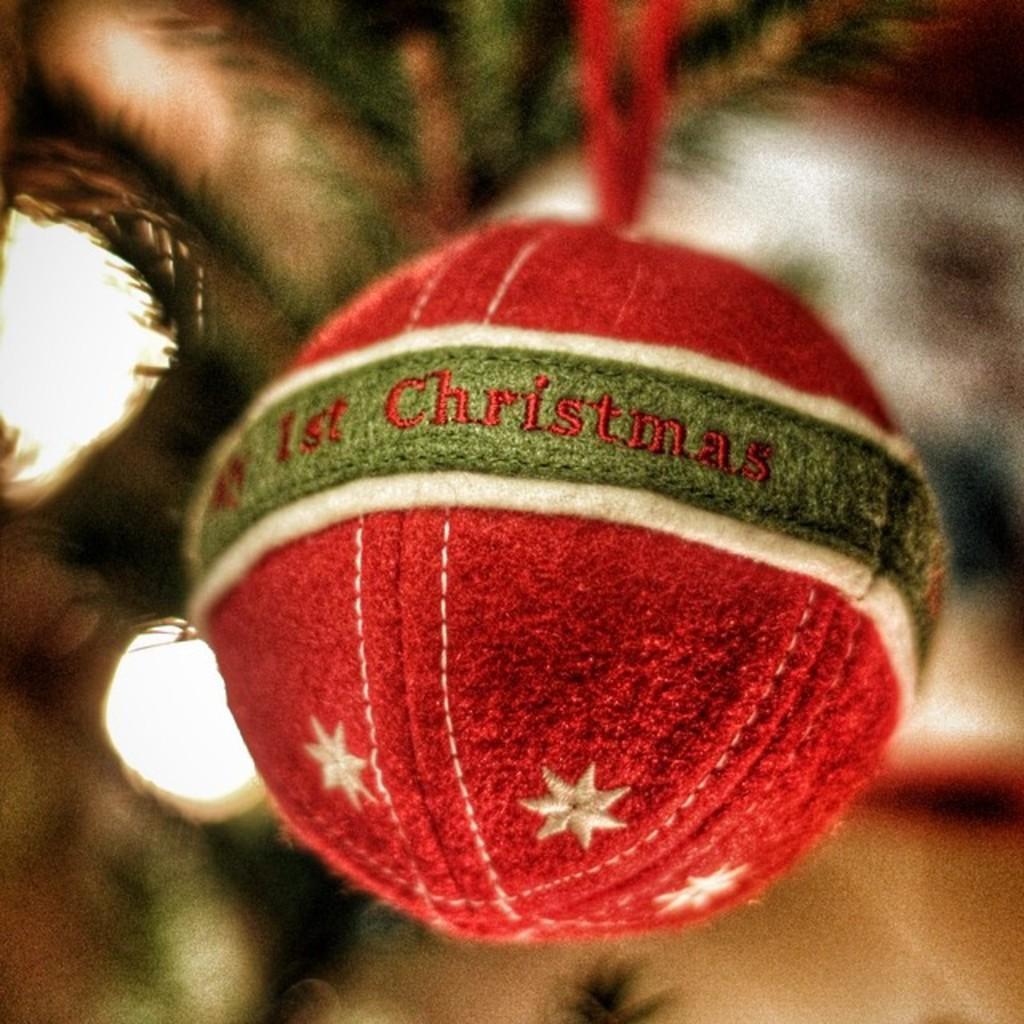How would you summarize this image in a sentence or two? In this image there is a red color Christmas ornament in the middle. In the background there is a Christmas tree with the lights. There are stars on the Christmas ball. 